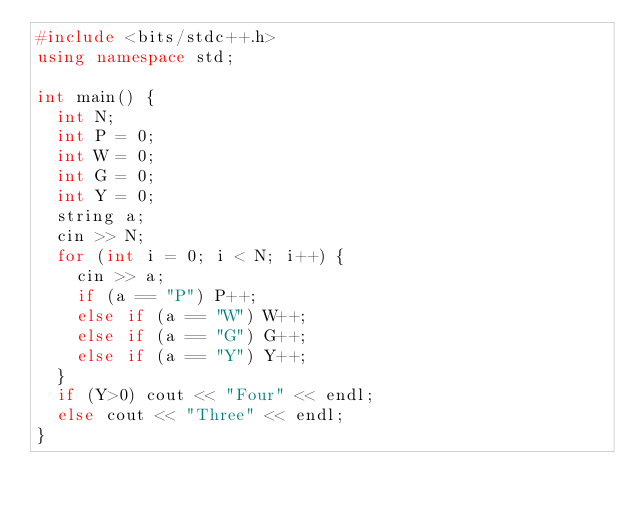<code> <loc_0><loc_0><loc_500><loc_500><_C++_>#include <bits/stdc++.h>
using namespace std;

int main() {
  int N;
  int P = 0;
  int W = 0;
  int G = 0;
  int Y = 0;
  string a;
  cin >> N;
  for (int i = 0; i < N; i++) {
    cin >> a;
    if (a == "P") P++;
    else if (a == "W") W++;
    else if (a == "G") G++;
    else if (a == "Y") Y++;
  }
  if (Y>0) cout << "Four" << endl;
  else cout << "Three" << endl;
}</code> 